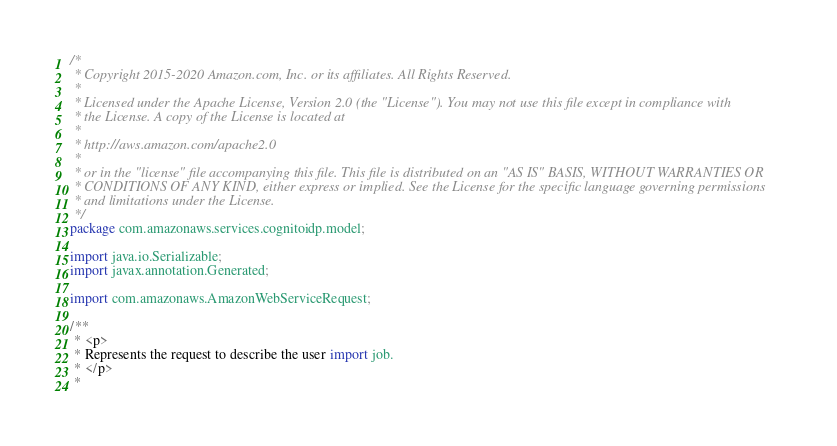<code> <loc_0><loc_0><loc_500><loc_500><_Java_>/*
 * Copyright 2015-2020 Amazon.com, Inc. or its affiliates. All Rights Reserved.
 * 
 * Licensed under the Apache License, Version 2.0 (the "License"). You may not use this file except in compliance with
 * the License. A copy of the License is located at
 * 
 * http://aws.amazon.com/apache2.0
 * 
 * or in the "license" file accompanying this file. This file is distributed on an "AS IS" BASIS, WITHOUT WARRANTIES OR
 * CONDITIONS OF ANY KIND, either express or implied. See the License for the specific language governing permissions
 * and limitations under the License.
 */
package com.amazonaws.services.cognitoidp.model;

import java.io.Serializable;
import javax.annotation.Generated;

import com.amazonaws.AmazonWebServiceRequest;

/**
 * <p>
 * Represents the request to describe the user import job.
 * </p>
 * </code> 